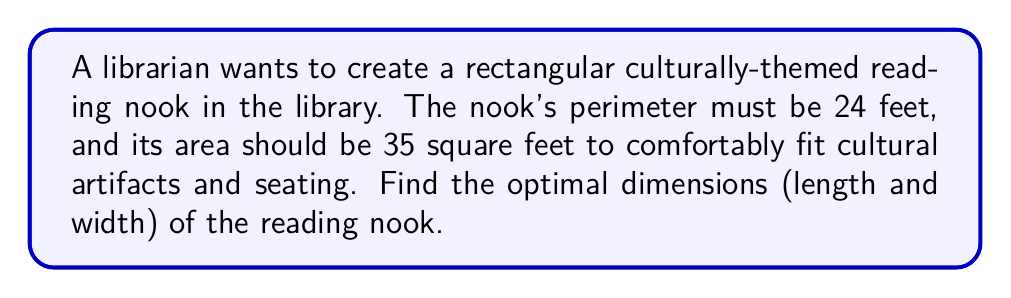Teach me how to tackle this problem. Let's approach this step-by-step using a system of linear equations:

1) Let $x$ be the length and $y$ be the width of the reading nook.

2) Given the perimeter is 24 feet, we can write:
   $2x + 2y = 24$
   Simplifying: $x + y = 12$ ... (Equation 1)

3) The area should be 35 square feet:
   $xy = 35$ ... (Equation 2)

4) From Equation 1, we can express $y$ in terms of $x$:
   $y = 12 - x$

5) Substitute this into Equation 2:
   $x(12 - x) = 35$
   $12x - x^2 = 35$

6) Rearrange to standard quadratic form:
   $x^2 - 12x + 35 = 0$

7) Solve using the quadratic formula: $x = \frac{-b \pm \sqrt{b^2 - 4ac}}{2a}$
   Where $a=1$, $b=-12$, and $c=35$

   $x = \frac{12 \pm \sqrt{144 - 140}}{2} = \frac{12 \pm 2}{2}$

8) This gives us two solutions:
   $x_1 = \frac{12 + 2}{2} = 7$ and $x_2 = \frac{12 - 2}{2} = 5$

9) The corresponding $y$ values are:
   For $x_1 = 7$: $y_1 = 12 - 7 = 5$
   For $x_2 = 5$: $y_2 = 12 - 5 = 7$

Both solutions (7,5) and (5,7) satisfy our conditions. The nook can be 7 feet long and 5 feet wide, or 5 feet long and 7 feet wide.
Answer: 7 feet by 5 feet or 5 feet by 7 feet 